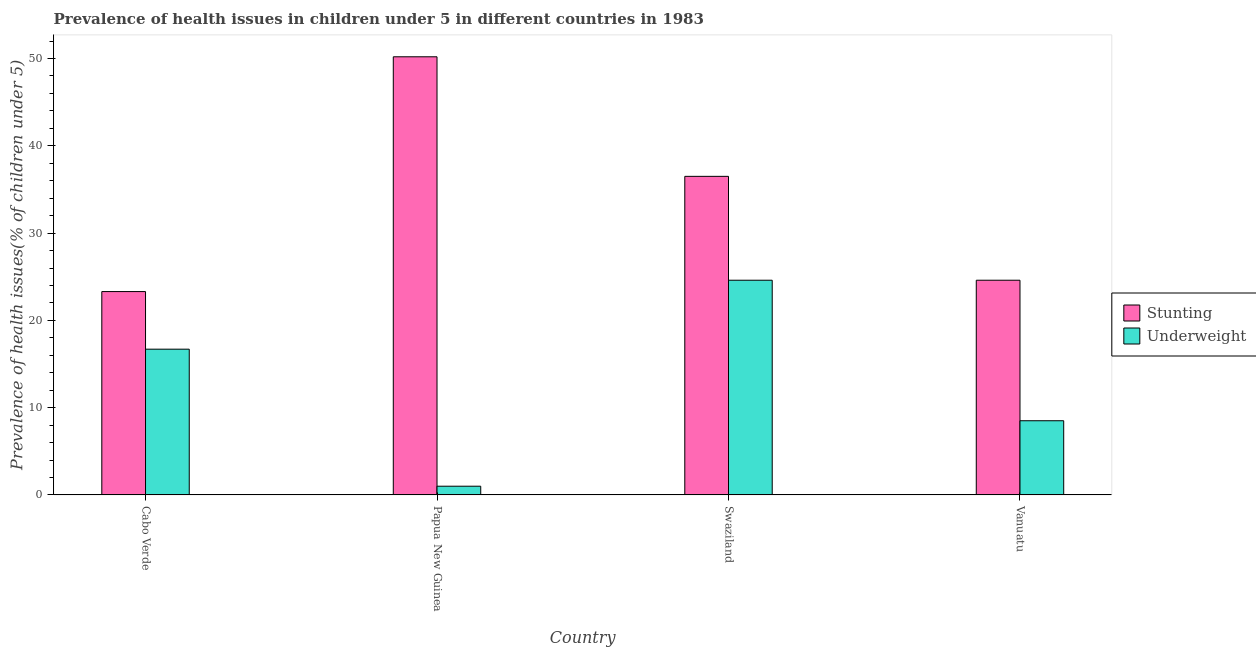How many different coloured bars are there?
Your answer should be compact. 2. How many groups of bars are there?
Ensure brevity in your answer.  4. Are the number of bars on each tick of the X-axis equal?
Ensure brevity in your answer.  Yes. How many bars are there on the 4th tick from the left?
Your answer should be very brief. 2. What is the label of the 1st group of bars from the left?
Your answer should be very brief. Cabo Verde. In how many cases, is the number of bars for a given country not equal to the number of legend labels?
Offer a very short reply. 0. What is the percentage of underweight children in Swaziland?
Your answer should be very brief. 24.6. Across all countries, what is the maximum percentage of underweight children?
Keep it short and to the point. 24.6. In which country was the percentage of stunted children maximum?
Keep it short and to the point. Papua New Guinea. In which country was the percentage of underweight children minimum?
Your answer should be very brief. Papua New Guinea. What is the total percentage of underweight children in the graph?
Ensure brevity in your answer.  50.8. What is the difference between the percentage of underweight children in Cabo Verde and that in Swaziland?
Offer a terse response. -7.9. What is the difference between the percentage of underweight children in Cabo Verde and the percentage of stunted children in Papua New Guinea?
Your answer should be very brief. -33.5. What is the average percentage of underweight children per country?
Provide a short and direct response. 12.7. What is the difference between the percentage of stunted children and percentage of underweight children in Papua New Guinea?
Provide a succinct answer. 49.2. What is the ratio of the percentage of stunted children in Cabo Verde to that in Papua New Guinea?
Your answer should be very brief. 0.46. What is the difference between the highest and the second highest percentage of underweight children?
Your response must be concise. 7.9. What is the difference between the highest and the lowest percentage of stunted children?
Provide a short and direct response. 26.9. In how many countries, is the percentage of stunted children greater than the average percentage of stunted children taken over all countries?
Provide a short and direct response. 2. Is the sum of the percentage of underweight children in Cabo Verde and Papua New Guinea greater than the maximum percentage of stunted children across all countries?
Your answer should be very brief. No. What does the 1st bar from the left in Cabo Verde represents?
Make the answer very short. Stunting. What does the 1st bar from the right in Vanuatu represents?
Your response must be concise. Underweight. Are all the bars in the graph horizontal?
Give a very brief answer. No. What is the difference between two consecutive major ticks on the Y-axis?
Ensure brevity in your answer.  10. Does the graph contain any zero values?
Keep it short and to the point. No. Does the graph contain grids?
Offer a terse response. No. Where does the legend appear in the graph?
Give a very brief answer. Center right. How are the legend labels stacked?
Offer a very short reply. Vertical. What is the title of the graph?
Ensure brevity in your answer.  Prevalence of health issues in children under 5 in different countries in 1983. Does "Lowest 10% of population" appear as one of the legend labels in the graph?
Provide a short and direct response. No. What is the label or title of the Y-axis?
Provide a succinct answer. Prevalence of health issues(% of children under 5). What is the Prevalence of health issues(% of children under 5) of Stunting in Cabo Verde?
Offer a terse response. 23.3. What is the Prevalence of health issues(% of children under 5) of Underweight in Cabo Verde?
Provide a short and direct response. 16.7. What is the Prevalence of health issues(% of children under 5) of Stunting in Papua New Guinea?
Provide a short and direct response. 50.2. What is the Prevalence of health issues(% of children under 5) in Underweight in Papua New Guinea?
Give a very brief answer. 1. What is the Prevalence of health issues(% of children under 5) of Stunting in Swaziland?
Give a very brief answer. 36.5. What is the Prevalence of health issues(% of children under 5) of Underweight in Swaziland?
Your response must be concise. 24.6. What is the Prevalence of health issues(% of children under 5) of Stunting in Vanuatu?
Make the answer very short. 24.6. What is the Prevalence of health issues(% of children under 5) of Underweight in Vanuatu?
Offer a very short reply. 8.5. Across all countries, what is the maximum Prevalence of health issues(% of children under 5) of Stunting?
Make the answer very short. 50.2. Across all countries, what is the maximum Prevalence of health issues(% of children under 5) in Underweight?
Your response must be concise. 24.6. Across all countries, what is the minimum Prevalence of health issues(% of children under 5) of Stunting?
Ensure brevity in your answer.  23.3. Across all countries, what is the minimum Prevalence of health issues(% of children under 5) of Underweight?
Your answer should be very brief. 1. What is the total Prevalence of health issues(% of children under 5) of Stunting in the graph?
Keep it short and to the point. 134.6. What is the total Prevalence of health issues(% of children under 5) of Underweight in the graph?
Your answer should be very brief. 50.8. What is the difference between the Prevalence of health issues(% of children under 5) in Stunting in Cabo Verde and that in Papua New Guinea?
Your response must be concise. -26.9. What is the difference between the Prevalence of health issues(% of children under 5) of Underweight in Cabo Verde and that in Papua New Guinea?
Offer a very short reply. 15.7. What is the difference between the Prevalence of health issues(% of children under 5) in Stunting in Cabo Verde and that in Swaziland?
Ensure brevity in your answer.  -13.2. What is the difference between the Prevalence of health issues(% of children under 5) of Underweight in Cabo Verde and that in Swaziland?
Give a very brief answer. -7.9. What is the difference between the Prevalence of health issues(% of children under 5) of Stunting in Cabo Verde and that in Vanuatu?
Give a very brief answer. -1.3. What is the difference between the Prevalence of health issues(% of children under 5) in Underweight in Papua New Guinea and that in Swaziland?
Ensure brevity in your answer.  -23.6. What is the difference between the Prevalence of health issues(% of children under 5) of Stunting in Papua New Guinea and that in Vanuatu?
Offer a very short reply. 25.6. What is the difference between the Prevalence of health issues(% of children under 5) of Underweight in Papua New Guinea and that in Vanuatu?
Provide a short and direct response. -7.5. What is the difference between the Prevalence of health issues(% of children under 5) in Stunting in Swaziland and that in Vanuatu?
Provide a short and direct response. 11.9. What is the difference between the Prevalence of health issues(% of children under 5) of Stunting in Cabo Verde and the Prevalence of health issues(% of children under 5) of Underweight in Papua New Guinea?
Give a very brief answer. 22.3. What is the difference between the Prevalence of health issues(% of children under 5) in Stunting in Cabo Verde and the Prevalence of health issues(% of children under 5) in Underweight in Swaziland?
Give a very brief answer. -1.3. What is the difference between the Prevalence of health issues(% of children under 5) of Stunting in Cabo Verde and the Prevalence of health issues(% of children under 5) of Underweight in Vanuatu?
Provide a short and direct response. 14.8. What is the difference between the Prevalence of health issues(% of children under 5) of Stunting in Papua New Guinea and the Prevalence of health issues(% of children under 5) of Underweight in Swaziland?
Offer a very short reply. 25.6. What is the difference between the Prevalence of health issues(% of children under 5) of Stunting in Papua New Guinea and the Prevalence of health issues(% of children under 5) of Underweight in Vanuatu?
Your answer should be very brief. 41.7. What is the average Prevalence of health issues(% of children under 5) in Stunting per country?
Offer a very short reply. 33.65. What is the average Prevalence of health issues(% of children under 5) of Underweight per country?
Your response must be concise. 12.7. What is the difference between the Prevalence of health issues(% of children under 5) of Stunting and Prevalence of health issues(% of children under 5) of Underweight in Cabo Verde?
Provide a succinct answer. 6.6. What is the difference between the Prevalence of health issues(% of children under 5) of Stunting and Prevalence of health issues(% of children under 5) of Underweight in Papua New Guinea?
Your answer should be compact. 49.2. What is the difference between the Prevalence of health issues(% of children under 5) in Stunting and Prevalence of health issues(% of children under 5) in Underweight in Swaziland?
Your answer should be very brief. 11.9. What is the ratio of the Prevalence of health issues(% of children under 5) of Stunting in Cabo Verde to that in Papua New Guinea?
Offer a terse response. 0.46. What is the ratio of the Prevalence of health issues(% of children under 5) in Stunting in Cabo Verde to that in Swaziland?
Your response must be concise. 0.64. What is the ratio of the Prevalence of health issues(% of children under 5) in Underweight in Cabo Verde to that in Swaziland?
Your response must be concise. 0.68. What is the ratio of the Prevalence of health issues(% of children under 5) in Stunting in Cabo Verde to that in Vanuatu?
Your answer should be very brief. 0.95. What is the ratio of the Prevalence of health issues(% of children under 5) of Underweight in Cabo Verde to that in Vanuatu?
Make the answer very short. 1.96. What is the ratio of the Prevalence of health issues(% of children under 5) in Stunting in Papua New Guinea to that in Swaziland?
Offer a terse response. 1.38. What is the ratio of the Prevalence of health issues(% of children under 5) of Underweight in Papua New Guinea to that in Swaziland?
Offer a terse response. 0.04. What is the ratio of the Prevalence of health issues(% of children under 5) in Stunting in Papua New Guinea to that in Vanuatu?
Provide a succinct answer. 2.04. What is the ratio of the Prevalence of health issues(% of children under 5) of Underweight in Papua New Guinea to that in Vanuatu?
Offer a terse response. 0.12. What is the ratio of the Prevalence of health issues(% of children under 5) of Stunting in Swaziland to that in Vanuatu?
Ensure brevity in your answer.  1.48. What is the ratio of the Prevalence of health issues(% of children under 5) of Underweight in Swaziland to that in Vanuatu?
Give a very brief answer. 2.89. What is the difference between the highest and the lowest Prevalence of health issues(% of children under 5) in Stunting?
Provide a short and direct response. 26.9. What is the difference between the highest and the lowest Prevalence of health issues(% of children under 5) in Underweight?
Your answer should be very brief. 23.6. 